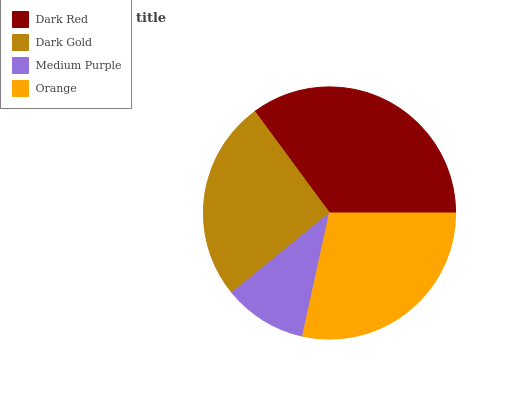Is Medium Purple the minimum?
Answer yes or no. Yes. Is Dark Red the maximum?
Answer yes or no. Yes. Is Dark Gold the minimum?
Answer yes or no. No. Is Dark Gold the maximum?
Answer yes or no. No. Is Dark Red greater than Dark Gold?
Answer yes or no. Yes. Is Dark Gold less than Dark Red?
Answer yes or no. Yes. Is Dark Gold greater than Dark Red?
Answer yes or no. No. Is Dark Red less than Dark Gold?
Answer yes or no. No. Is Orange the high median?
Answer yes or no. Yes. Is Dark Gold the low median?
Answer yes or no. Yes. Is Medium Purple the high median?
Answer yes or no. No. Is Medium Purple the low median?
Answer yes or no. No. 